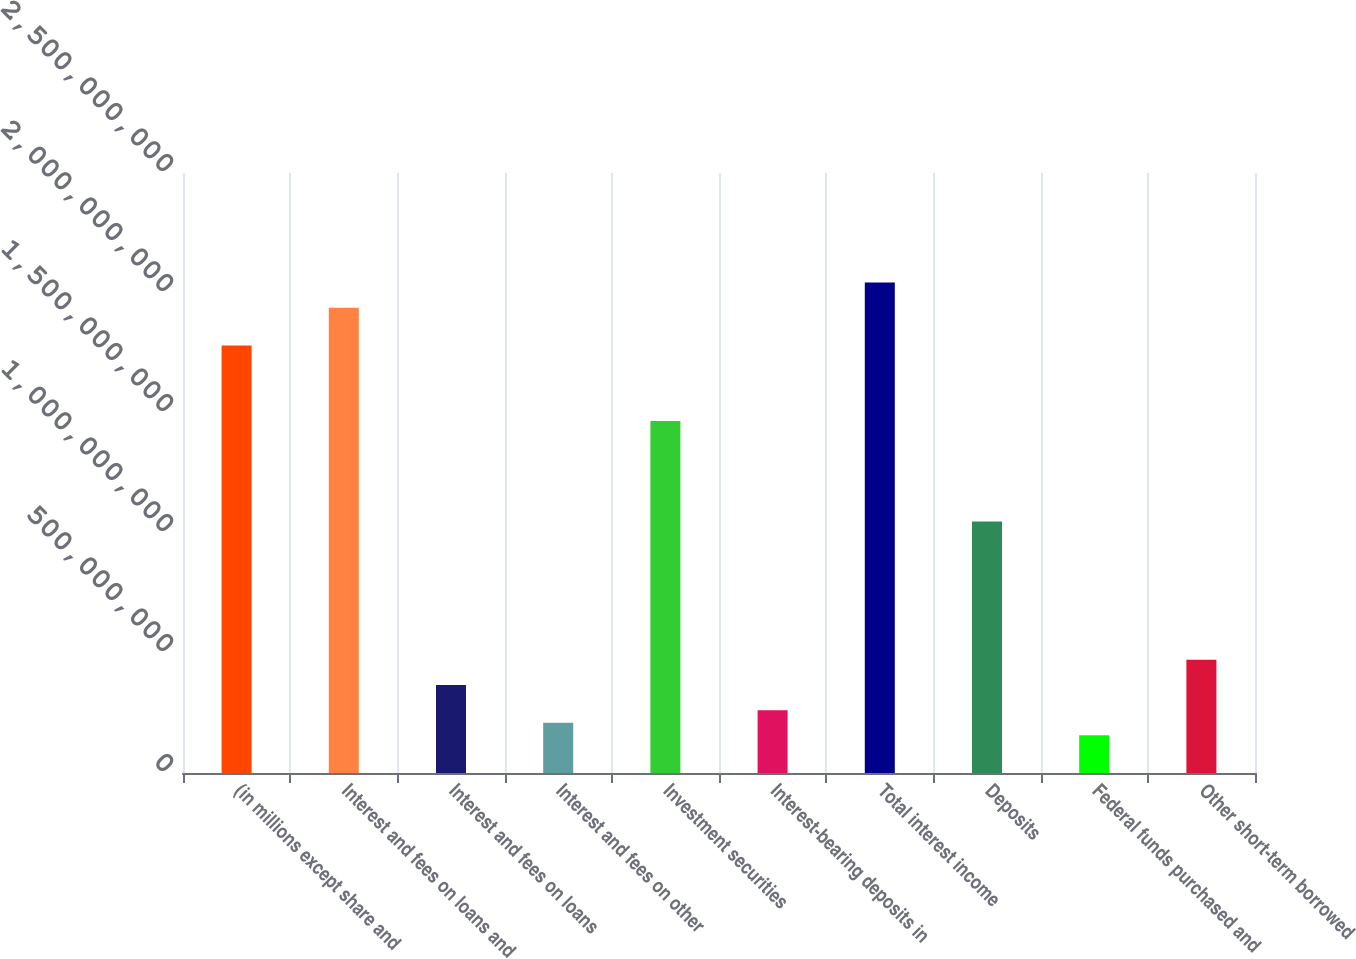Convert chart to OTSL. <chart><loc_0><loc_0><loc_500><loc_500><bar_chart><fcel>(in millions except share and<fcel>Interest and fees on loans and<fcel>Interest and fees on loans<fcel>Interest and fees on other<fcel>Investment securities<fcel>Interest-bearing deposits in<fcel>Total interest income<fcel>Deposits<fcel>Federal funds purchased and<fcel>Other short-term borrowed<nl><fcel>1.78136e+09<fcel>1.93854e+09<fcel>3.66752e+08<fcel>2.09572e+08<fcel>1.46701e+09<fcel>2.61965e+08<fcel>2.04333e+09<fcel>1.04786e+09<fcel>1.57179e+08<fcel>4.71538e+08<nl></chart> 